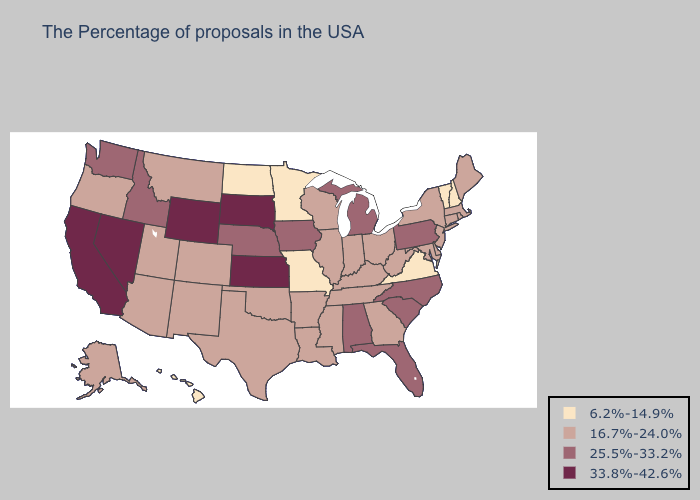What is the value of California?
Answer briefly. 33.8%-42.6%. Does Iowa have the same value as Massachusetts?
Concise answer only. No. Does the first symbol in the legend represent the smallest category?
Keep it brief. Yes. Does Wisconsin have a lower value than Texas?
Be succinct. No. Which states have the highest value in the USA?
Keep it brief. Kansas, South Dakota, Wyoming, Nevada, California. Name the states that have a value in the range 16.7%-24.0%?
Keep it brief. Maine, Massachusetts, Rhode Island, Connecticut, New York, New Jersey, Delaware, Maryland, West Virginia, Ohio, Georgia, Kentucky, Indiana, Tennessee, Wisconsin, Illinois, Mississippi, Louisiana, Arkansas, Oklahoma, Texas, Colorado, New Mexico, Utah, Montana, Arizona, Oregon, Alaska. What is the highest value in the USA?
Quick response, please. 33.8%-42.6%. Among the states that border Ohio , does West Virginia have the lowest value?
Quick response, please. Yes. Name the states that have a value in the range 33.8%-42.6%?
Quick response, please. Kansas, South Dakota, Wyoming, Nevada, California. What is the highest value in states that border New Jersey?
Concise answer only. 25.5%-33.2%. What is the value of North Carolina?
Answer briefly. 25.5%-33.2%. Does Rhode Island have the highest value in the USA?
Write a very short answer. No. Among the states that border Kentucky , which have the highest value?
Be succinct. West Virginia, Ohio, Indiana, Tennessee, Illinois. Name the states that have a value in the range 6.2%-14.9%?
Short answer required. New Hampshire, Vermont, Virginia, Missouri, Minnesota, North Dakota, Hawaii. Among the states that border Colorado , does New Mexico have the highest value?
Quick response, please. No. 